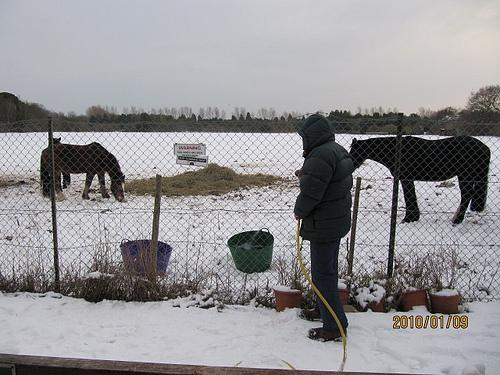What will happen to the water in the hose?

Choices:
A) evaporate
B) freeze
C) melt snow
D) horses drink horses drink 